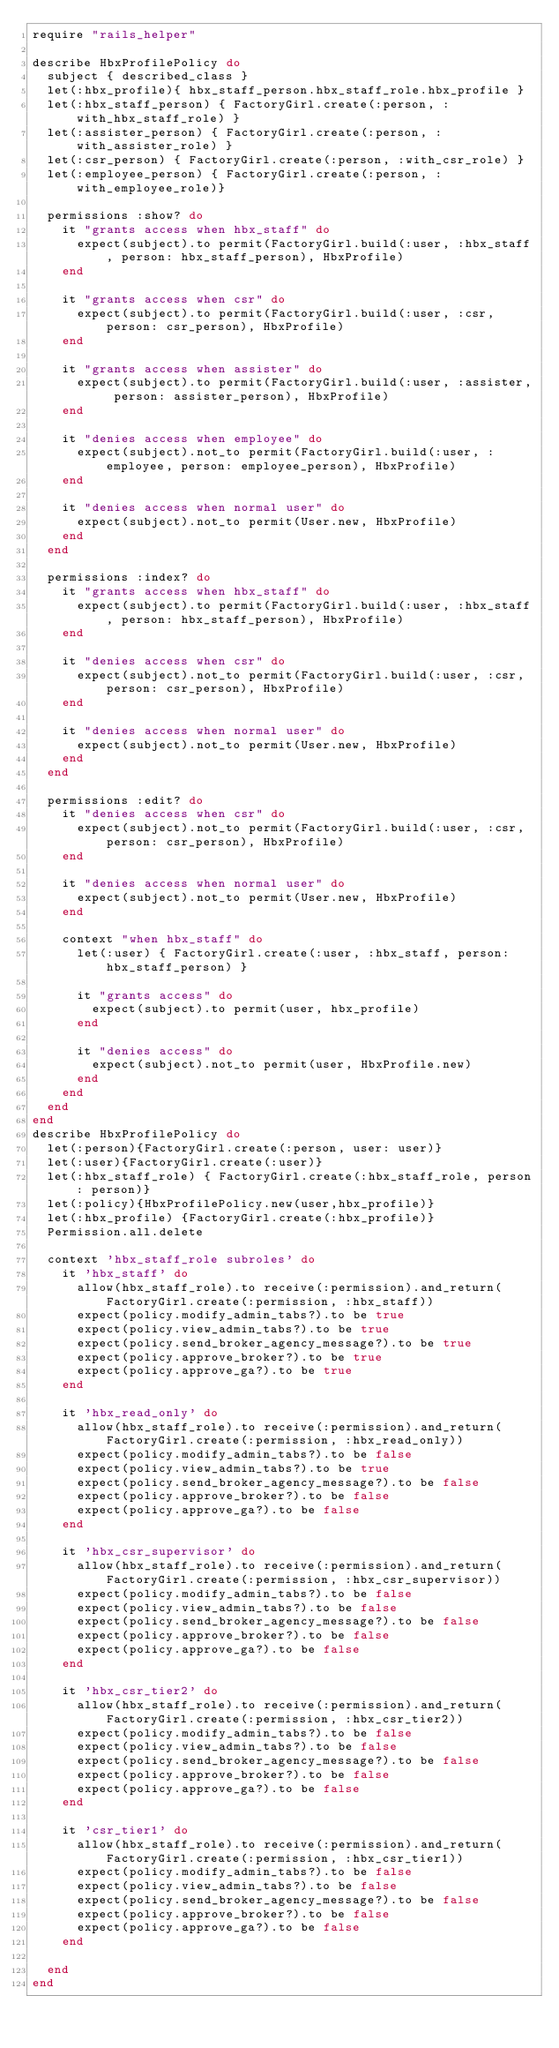Convert code to text. <code><loc_0><loc_0><loc_500><loc_500><_Ruby_>require "rails_helper"

describe HbxProfilePolicy do
  subject { described_class }
  let(:hbx_profile){ hbx_staff_person.hbx_staff_role.hbx_profile }
  let(:hbx_staff_person) { FactoryGirl.create(:person, :with_hbx_staff_role) }
  let(:assister_person) { FactoryGirl.create(:person, :with_assister_role) }
  let(:csr_person) { FactoryGirl.create(:person, :with_csr_role) }
  let(:employee_person) { FactoryGirl.create(:person, :with_employee_role)}

  permissions :show? do
    it "grants access when hbx_staff" do
      expect(subject).to permit(FactoryGirl.build(:user, :hbx_staff, person: hbx_staff_person), HbxProfile)
    end

    it "grants access when csr" do
      expect(subject).to permit(FactoryGirl.build(:user, :csr, person: csr_person), HbxProfile)
    end

    it "grants access when assister" do
      expect(subject).to permit(FactoryGirl.build(:user, :assister, person: assister_person), HbxProfile)
    end

    it "denies access when employee" do
      expect(subject).not_to permit(FactoryGirl.build(:user, :employee, person: employee_person), HbxProfile)
    end

    it "denies access when normal user" do
      expect(subject).not_to permit(User.new, HbxProfile)
    end
  end

  permissions :index? do
    it "grants access when hbx_staff" do
      expect(subject).to permit(FactoryGirl.build(:user, :hbx_staff, person: hbx_staff_person), HbxProfile)
    end

    it "denies access when csr" do
      expect(subject).not_to permit(FactoryGirl.build(:user, :csr, person: csr_person), HbxProfile)
    end

    it "denies access when normal user" do
      expect(subject).not_to permit(User.new, HbxProfile)
    end
  end

  permissions :edit? do
    it "denies access when csr" do
      expect(subject).not_to permit(FactoryGirl.build(:user, :csr, person: csr_person), HbxProfile)
    end

    it "denies access when normal user" do
      expect(subject).not_to permit(User.new, HbxProfile)
    end

    context "when hbx_staff" do
      let(:user) { FactoryGirl.create(:user, :hbx_staff, person: hbx_staff_person) }

      it "grants access" do
        expect(subject).to permit(user, hbx_profile)
      end

      it "denies access" do
        expect(subject).not_to permit(user, HbxProfile.new)
      end
    end
  end
end
describe HbxProfilePolicy do
  let(:person){FactoryGirl.create(:person, user: user)}
  let(:user){FactoryGirl.create(:user)}
  let(:hbx_staff_role) { FactoryGirl.create(:hbx_staff_role, person: person)}
  let(:policy){HbxProfilePolicy.new(user,hbx_profile)}
  let(:hbx_profile) {FactoryGirl.create(:hbx_profile)}
  Permission.all.delete

  context 'hbx_staff_role subroles' do
    it 'hbx_staff' do
      allow(hbx_staff_role).to receive(:permission).and_return(FactoryGirl.create(:permission, :hbx_staff))
      expect(policy.modify_admin_tabs?).to be true
      expect(policy.view_admin_tabs?).to be true
      expect(policy.send_broker_agency_message?).to be true
      expect(policy.approve_broker?).to be true
      expect(policy.approve_ga?).to be true
    end

    it 'hbx_read_only' do
      allow(hbx_staff_role).to receive(:permission).and_return(FactoryGirl.create(:permission, :hbx_read_only))
      expect(policy.modify_admin_tabs?).to be false
      expect(policy.view_admin_tabs?).to be true
      expect(policy.send_broker_agency_message?).to be false
      expect(policy.approve_broker?).to be false
      expect(policy.approve_ga?).to be false
    end

    it 'hbx_csr_supervisor' do
      allow(hbx_staff_role).to receive(:permission).and_return(FactoryGirl.create(:permission, :hbx_csr_supervisor))
      expect(policy.modify_admin_tabs?).to be false
      expect(policy.view_admin_tabs?).to be false
      expect(policy.send_broker_agency_message?).to be false
      expect(policy.approve_broker?).to be false
      expect(policy.approve_ga?).to be false
    end

    it 'hbx_csr_tier2' do
      allow(hbx_staff_role).to receive(:permission).and_return(FactoryGirl.create(:permission, :hbx_csr_tier2))
      expect(policy.modify_admin_tabs?).to be false
      expect(policy.view_admin_tabs?).to be false
      expect(policy.send_broker_agency_message?).to be false
      expect(policy.approve_broker?).to be false
      expect(policy.approve_ga?).to be false
    end

    it 'csr_tier1' do
      allow(hbx_staff_role).to receive(:permission).and_return(FactoryGirl.create(:permission, :hbx_csr_tier1))
      expect(policy.modify_admin_tabs?).to be false
      expect(policy.view_admin_tabs?).to be false
      expect(policy.send_broker_agency_message?).to be false
      expect(policy.approve_broker?).to be false
      expect(policy.approve_ga?).to be false
    end

  end
end</code> 